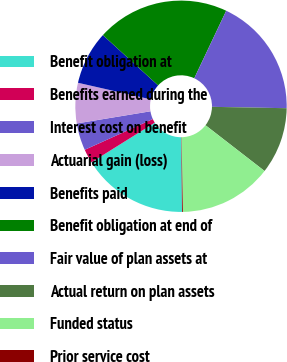Convert chart to OTSL. <chart><loc_0><loc_0><loc_500><loc_500><pie_chart><fcel>Benefit obligation at<fcel>Benefits earned during the<fcel>Interest cost on benefit<fcel>Actuarial gain (loss)<fcel>Benefits paid<fcel>Benefit obligation at end of<fcel>Fair value of plan assets at<fcel>Actual return on plan assets<fcel>Funded status<fcel>Prior service cost<nl><fcel>16.25%<fcel>2.14%<fcel>4.16%<fcel>6.17%<fcel>8.19%<fcel>20.28%<fcel>18.26%<fcel>10.2%<fcel>14.23%<fcel>0.13%<nl></chart> 